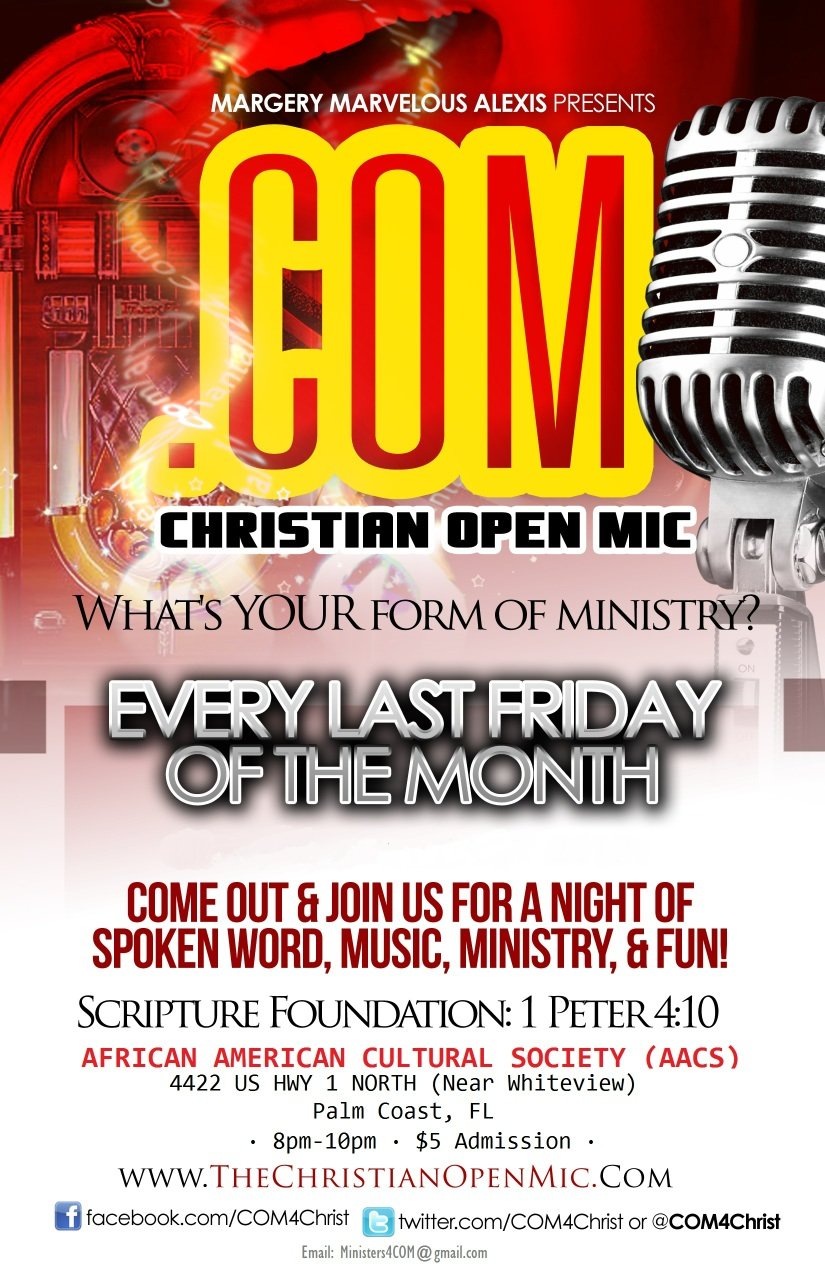What is the significance of the scripture 1 Peter 4:10 as mentioned in the flyer? 1 Peter 4:10 focuses on the theme of using one's gifts to serve others as faithful stewards of God's grace. The verse emphasizes generosity and community service, reflecting the Christian Open Mic's intention to foster an environment where individuals can share their gifts in ministry and creativity to uplift and inspire others. 